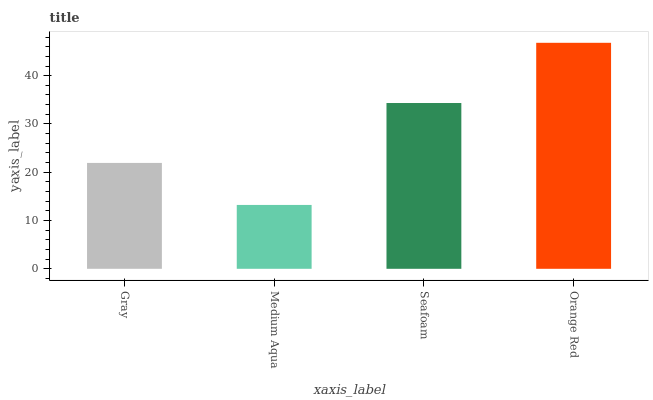Is Orange Red the maximum?
Answer yes or no. Yes. Is Seafoam the minimum?
Answer yes or no. No. Is Seafoam the maximum?
Answer yes or no. No. Is Seafoam greater than Medium Aqua?
Answer yes or no. Yes. Is Medium Aqua less than Seafoam?
Answer yes or no. Yes. Is Medium Aqua greater than Seafoam?
Answer yes or no. No. Is Seafoam less than Medium Aqua?
Answer yes or no. No. Is Seafoam the high median?
Answer yes or no. Yes. Is Gray the low median?
Answer yes or no. Yes. Is Medium Aqua the high median?
Answer yes or no. No. Is Seafoam the low median?
Answer yes or no. No. 